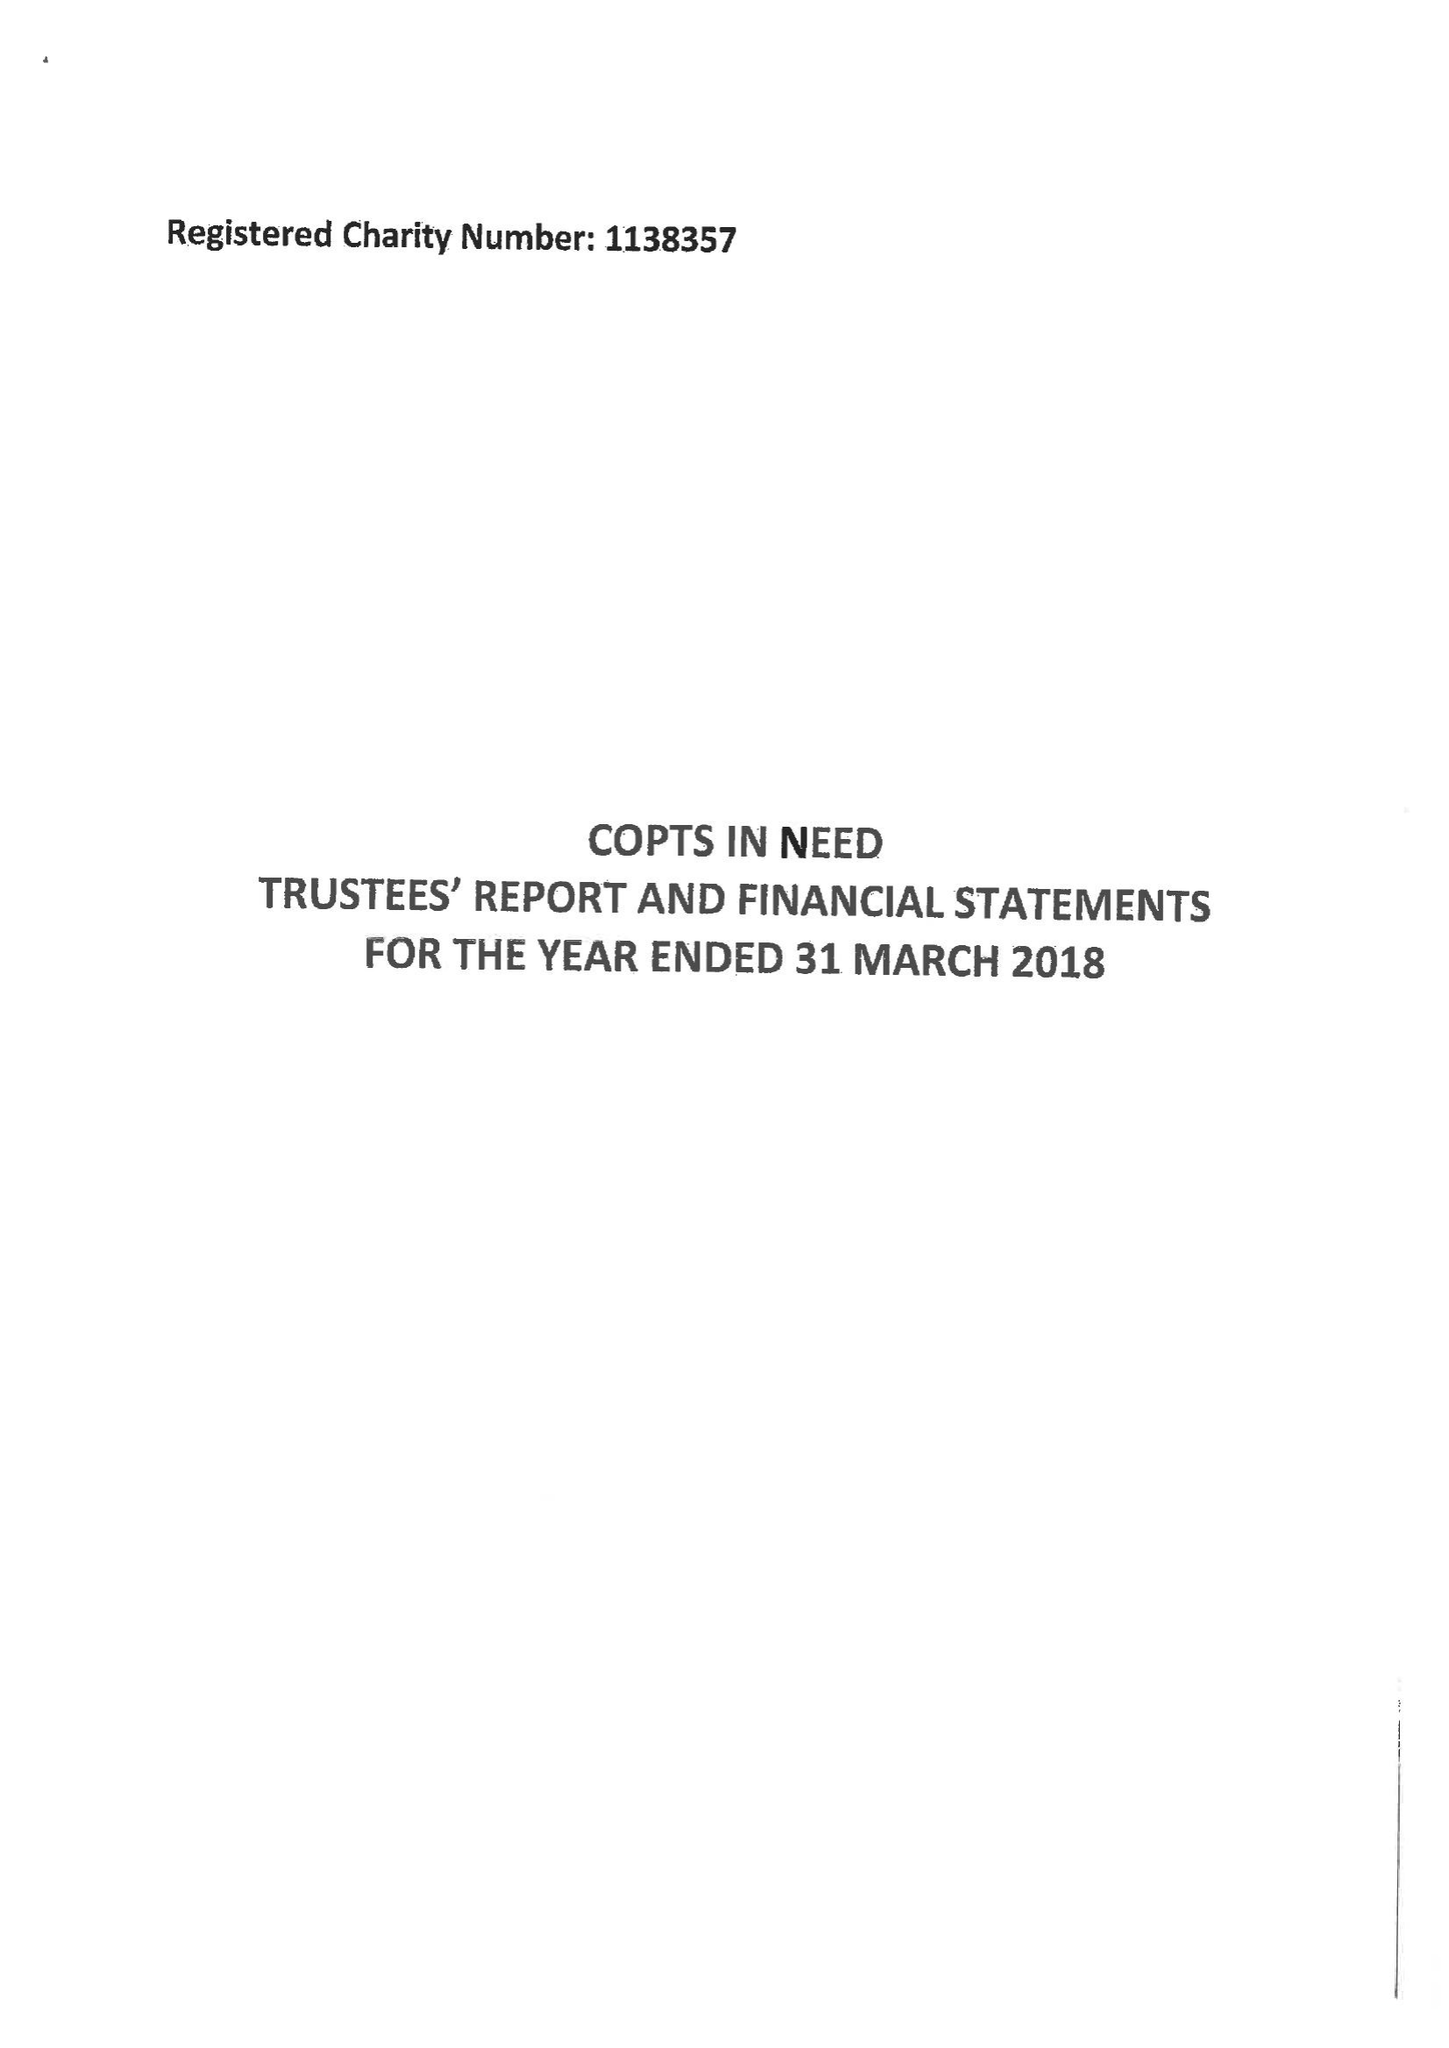What is the value for the charity_number?
Answer the question using a single word or phrase. 1138357 